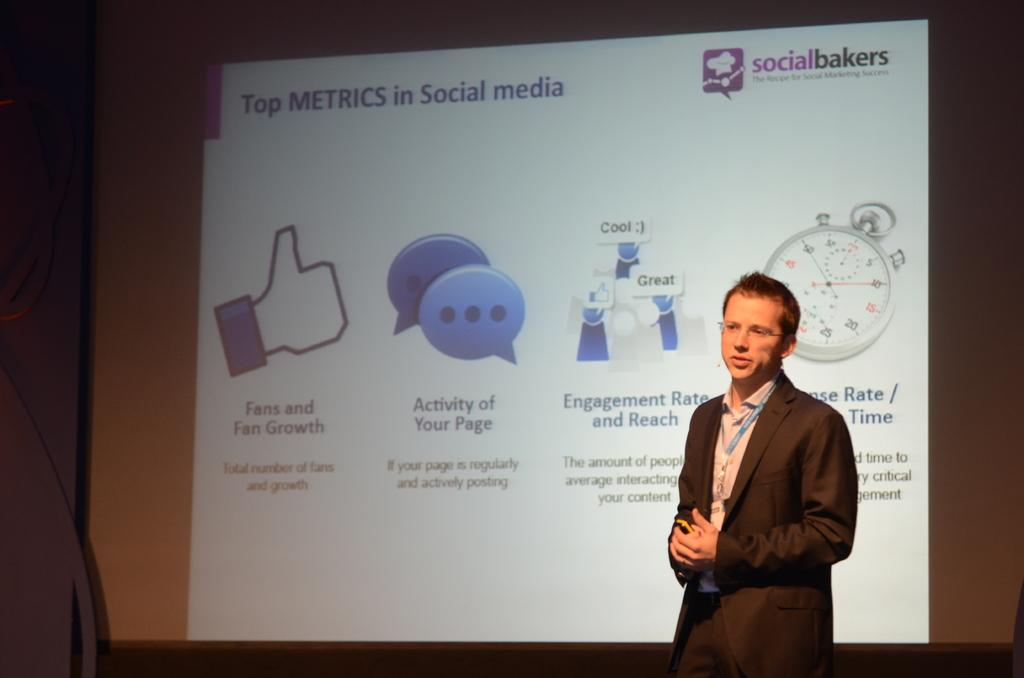What is the position of the person in the image? There is a person standing on the right side of the image. What can be seen in the background of the image? There is a screen in the background of the image. What is displayed on the screen? There are logos and text written on the screen. Can you see a kitten playing with a cabbage on the screen in the image? There is no kitten or cabbage present on the screen in the image; it displays logos and text. 